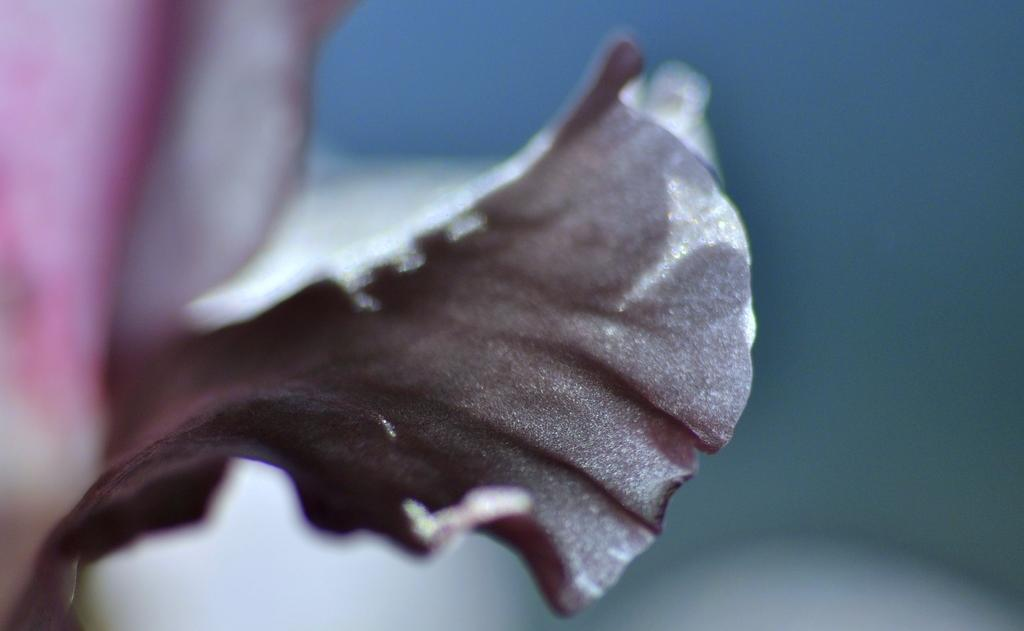What type of photography is used in the image? The image is a macro photography. Can you describe the background of the image? The background of the image is blurred. What type of soap is being used in the hospital room in the image? There is no hospital room or soap present in the image; it is a macro photography with a blurred background. 